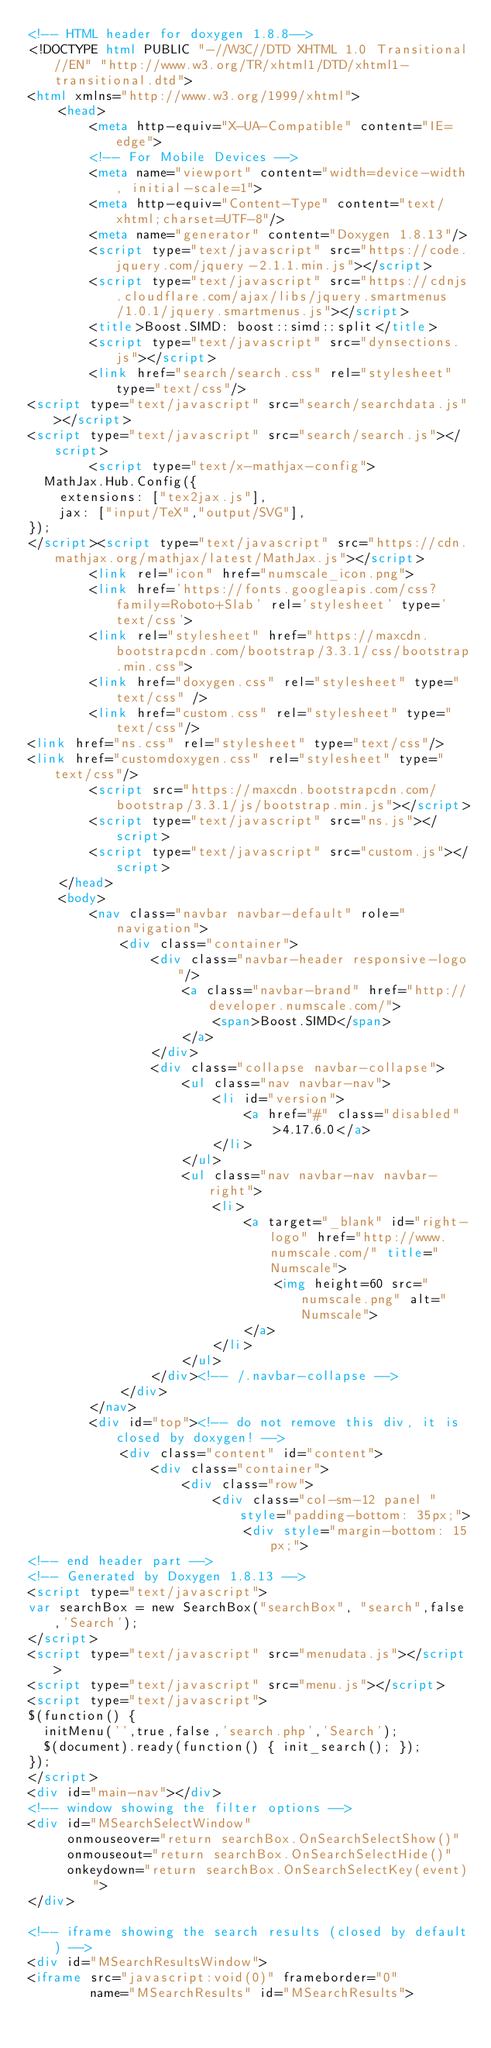Convert code to text. <code><loc_0><loc_0><loc_500><loc_500><_HTML_><!-- HTML header for doxygen 1.8.8-->
<!DOCTYPE html PUBLIC "-//W3C//DTD XHTML 1.0 Transitional//EN" "http://www.w3.org/TR/xhtml1/DTD/xhtml1-transitional.dtd">
<html xmlns="http://www.w3.org/1999/xhtml">
    <head>
        <meta http-equiv="X-UA-Compatible" content="IE=edge">
        <!-- For Mobile Devices -->
        <meta name="viewport" content="width=device-width, initial-scale=1">
        <meta http-equiv="Content-Type" content="text/xhtml;charset=UTF-8"/>
        <meta name="generator" content="Doxygen 1.8.13"/>
        <script type="text/javascript" src="https://code.jquery.com/jquery-2.1.1.min.js"></script>
        <script type="text/javascript" src="https://cdnjs.cloudflare.com/ajax/libs/jquery.smartmenus/1.0.1/jquery.smartmenus.js"></script>
        <title>Boost.SIMD: boost::simd::split</title>
        <script type="text/javascript" src="dynsections.js"></script>
        <link href="search/search.css" rel="stylesheet" type="text/css"/>
<script type="text/javascript" src="search/searchdata.js"></script>
<script type="text/javascript" src="search/search.js"></script>
        <script type="text/x-mathjax-config">
  MathJax.Hub.Config({
    extensions: ["tex2jax.js"],
    jax: ["input/TeX","output/SVG"],
});
</script><script type="text/javascript" src="https://cdn.mathjax.org/mathjax/latest/MathJax.js"></script>
        <link rel="icon" href="numscale_icon.png">
        <link href='https://fonts.googleapis.com/css?family=Roboto+Slab' rel='stylesheet' type='text/css'>
        <link rel="stylesheet" href="https://maxcdn.bootstrapcdn.com/bootstrap/3.3.1/css/bootstrap.min.css">
        <link href="doxygen.css" rel="stylesheet" type="text/css" />
        <link href="custom.css" rel="stylesheet" type="text/css"/>
<link href="ns.css" rel="stylesheet" type="text/css"/>
<link href="customdoxygen.css" rel="stylesheet" type="text/css"/>
        <script src="https://maxcdn.bootstrapcdn.com/bootstrap/3.3.1/js/bootstrap.min.js"></script>
        <script type="text/javascript" src="ns.js"></script>
        <script type="text/javascript" src="custom.js"></script>
    </head>
    <body>
        <nav class="navbar navbar-default" role="navigation">
            <div class="container">
                <div class="navbar-header responsive-logo"/>
                    <a class="navbar-brand" href="http://developer.numscale.com/">
                        <span>Boost.SIMD</span>
                    </a>
                </div>
                <div class="collapse navbar-collapse">
                    <ul class="nav navbar-nav">
                        <li id="version">
                            <a href="#" class="disabled">4.17.6.0</a>
                        </li>
                    </ul>
                    <ul class="nav navbar-nav navbar-right">
                        <li>
                            <a target="_blank" id="right-logo" href="http://www.numscale.com/" title="Numscale">
                                <img height=60 src="numscale.png" alt="Numscale">
                            </a>
                        </li>
                    </ul>
                </div><!-- /.navbar-collapse -->
            </div>
        </nav>
        <div id="top"><!-- do not remove this div, it is closed by doxygen! -->
            <div class="content" id="content">
                <div class="container">
                    <div class="row">
                        <div class="col-sm-12 panel " style="padding-bottom: 35px;">
                            <div style="margin-bottom: 15px;">
<!-- end header part -->
<!-- Generated by Doxygen 1.8.13 -->
<script type="text/javascript">
var searchBox = new SearchBox("searchBox", "search",false,'Search');
</script>
<script type="text/javascript" src="menudata.js"></script>
<script type="text/javascript" src="menu.js"></script>
<script type="text/javascript">
$(function() {
  initMenu('',true,false,'search.php','Search');
  $(document).ready(function() { init_search(); });
});
</script>
<div id="main-nav"></div>
<!-- window showing the filter options -->
<div id="MSearchSelectWindow"
     onmouseover="return searchBox.OnSearchSelectShow()"
     onmouseout="return searchBox.OnSearchSelectHide()"
     onkeydown="return searchBox.OnSearchSelectKey(event)">
</div>

<!-- iframe showing the search results (closed by default) -->
<div id="MSearchResultsWindow">
<iframe src="javascript:void(0)" frameborder="0" 
        name="MSearchResults" id="MSearchResults"></code> 